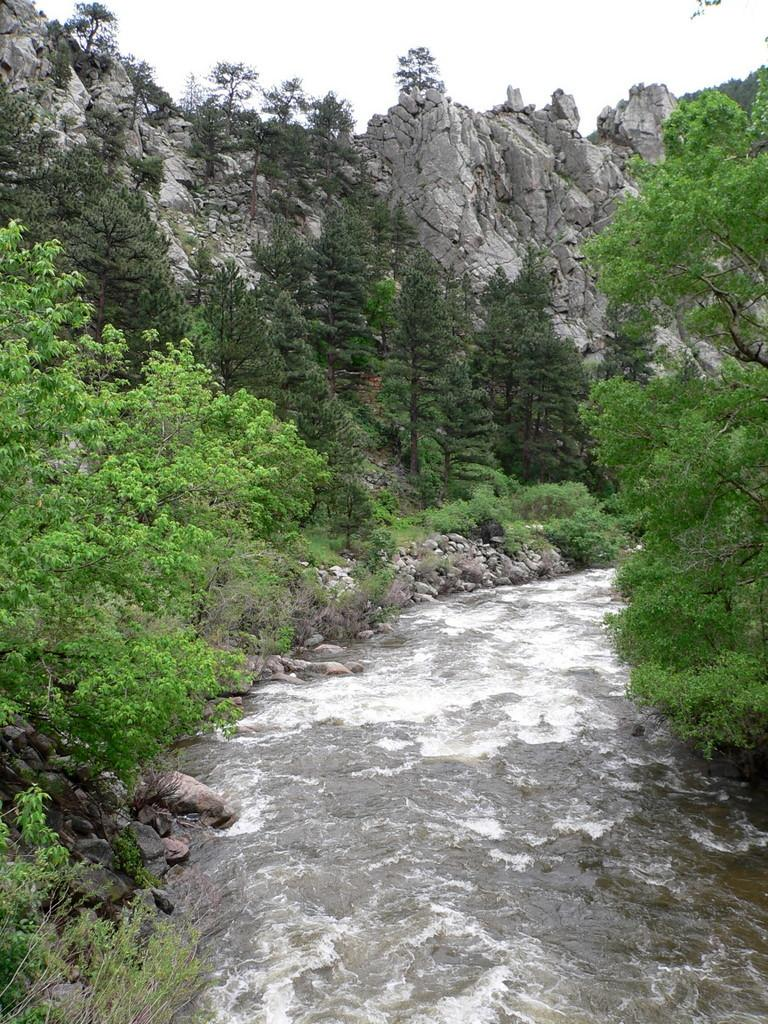What is visible in the image? Water is visible in the image. What can be seen on the left side of the image? There are trees on the left side of the image. What can be seen on the right side of the image? There are trees on the right side of the image. What type of natural features are present near the water? There are stones and rocks on the side of a lake in the image. What type of tooth is visible in the image? There is no tooth present in the image. Can you see a key hanging from the roof in the image? There is no roof or key present in the image. 